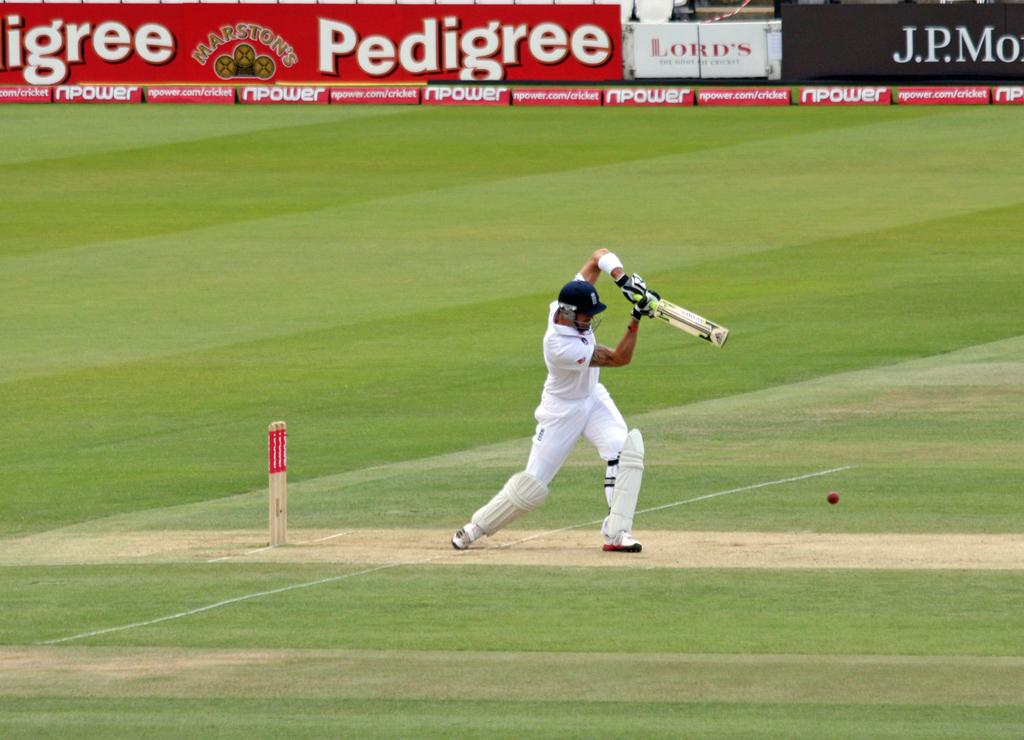<image>
Relay a brief, clear account of the picture shown. The ad in the red is for Marston's Pedigree 